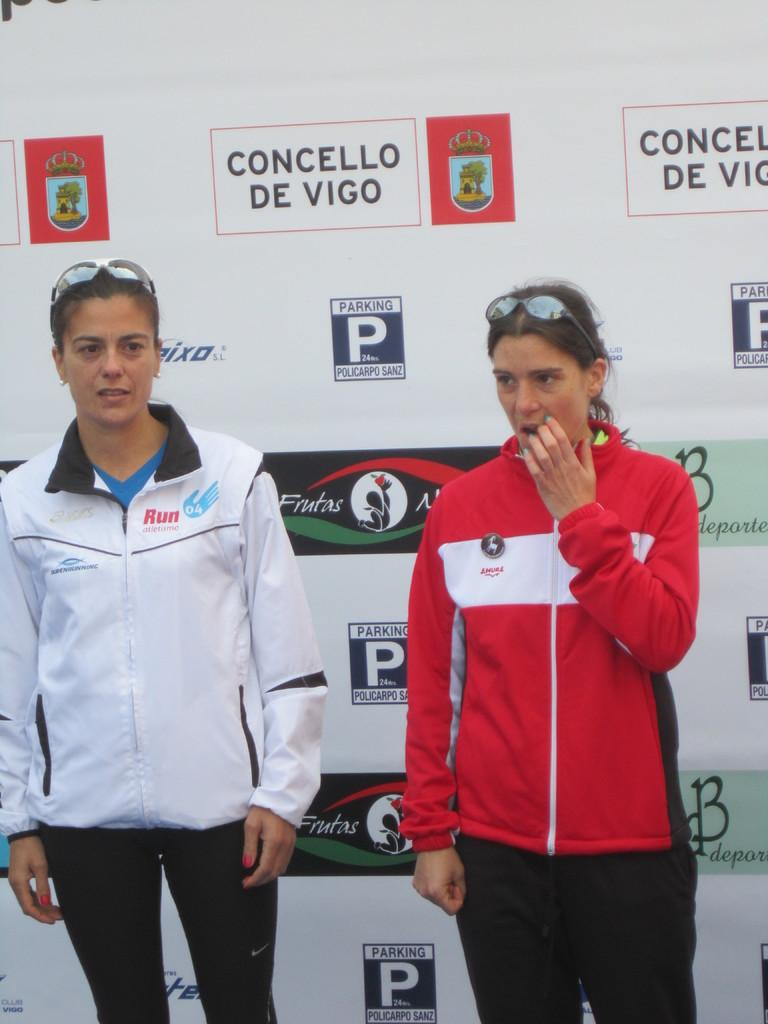Provide a one-sentence caption for the provided image. two women in from of a banner wall sponsored by Concello De Vigo. 